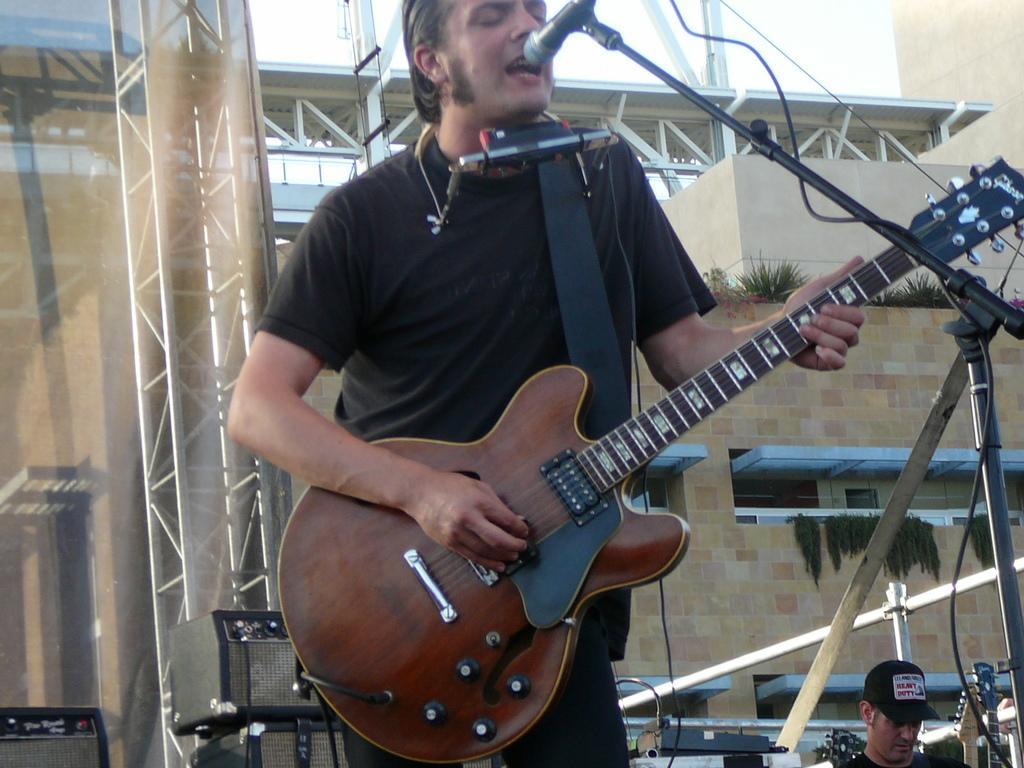How would you summarize this image in a sentence or two? In the middle a person is standing in front of the mike and playing guitar. In the background, a building is visible on which some plants are grown. At the bottom, a person half visible. In the middle, a sky visible of blue in color. This image is taken inside an open area. 